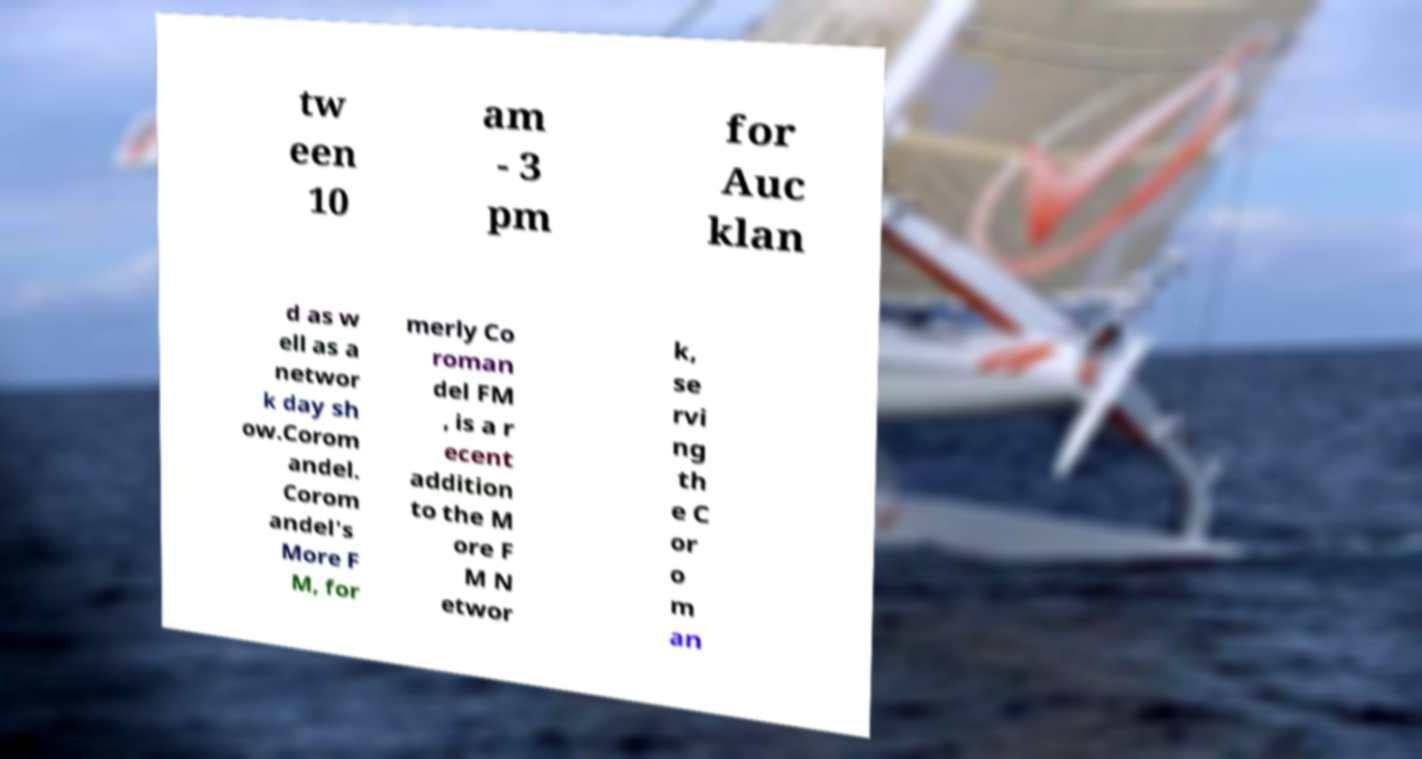Could you extract and type out the text from this image? tw een 10 am - 3 pm for Auc klan d as w ell as a networ k day sh ow.Corom andel. Corom andel's More F M, for merly Co roman del FM , is a r ecent addition to the M ore F M N etwor k, se rvi ng th e C or o m an 